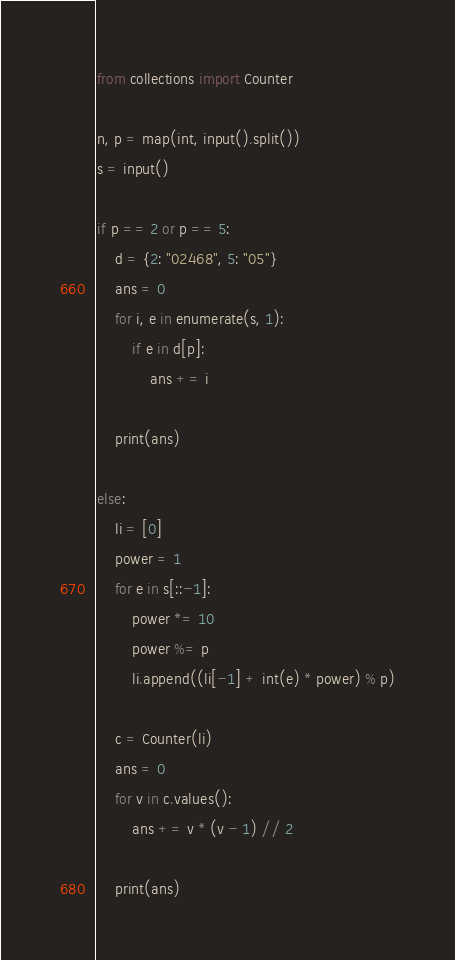<code> <loc_0><loc_0><loc_500><loc_500><_Python_>from collections import Counter

n, p = map(int, input().split())
s = input()

if p == 2 or p == 5:
    d = {2: "02468", 5: "05"}
    ans = 0
    for i, e in enumerate(s, 1):
        if e in d[p]:
            ans += i

    print(ans)

else:
    li = [0]
    power = 1
    for e in s[::-1]:
        power *= 10
        power %= p
        li.append((li[-1] + int(e) * power) % p)

    c = Counter(li)
    ans = 0
    for v in c.values():
        ans += v * (v - 1) // 2

    print(ans)
</code> 